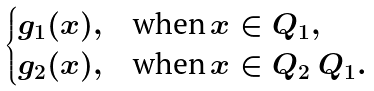<formula> <loc_0><loc_0><loc_500><loc_500>\begin{cases} g _ { 1 } ( x ) , & \text {when} \, x \in Q _ { 1 } , \\ g _ { 2 } ( x ) , & \text {when} \, x \in Q _ { 2 } \ Q _ { 1 } . \end{cases}</formula> 